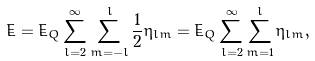Convert formula to latex. <formula><loc_0><loc_0><loc_500><loc_500>\dot { E } = \dot { E } _ { Q } \sum _ { l = 2 } ^ { \infty } \sum _ { m = - l } ^ { l } { \frac { 1 } { 2 } } \eta _ { l m } = \dot { E } _ { Q } \sum _ { l = 2 } ^ { \infty } \sum _ { m = 1 } ^ { l } \eta _ { l m } ,</formula> 